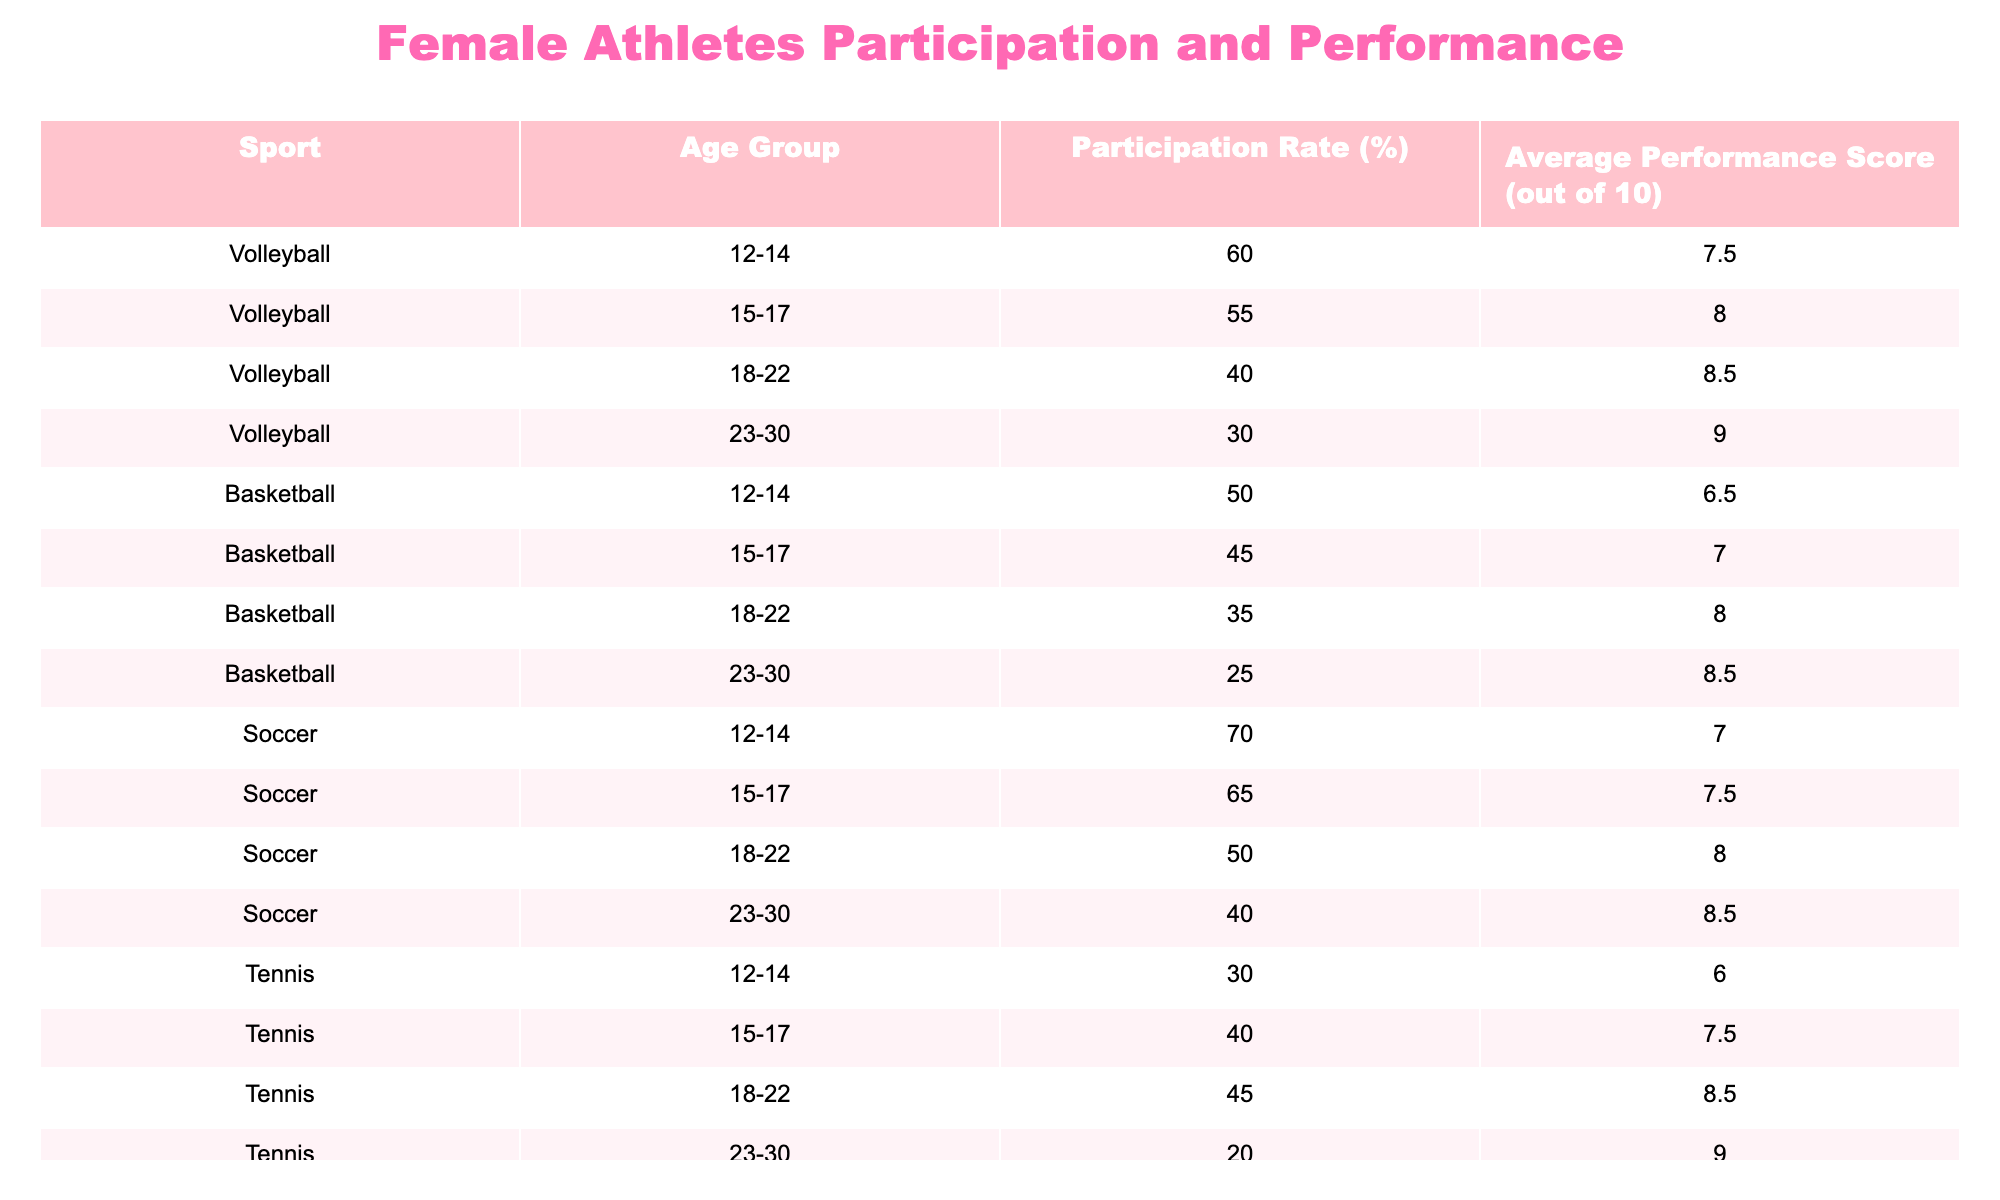What is the participation rate for female athletes in volleyball aged 12-14? According to the table, the participation rate for female athletes in volleyball in the age group of 12-14 is specified directly in the corresponding row, which shows a percentage of 60.
Answer: 60% What sport has the highest participation rate in the age group of 15-17? By comparing the participation rates across different sports for the age group of 15-17, volleyball has a participation rate of 55%, basketball has 45%, soccer has 65%, and tennis has 40%. Among these, soccer has the highest rate at 65%.
Answer: Soccer What is the average performance score for female athletes in tennis aged 18-22? The table indicates the average performance score for female athletes aged 18-22 in tennis, which is recorded directly as 8.5 in the relevant row of the table.
Answer: 8.5 Is the average performance score for basketball in the age group of 23-30 higher than that for soccer in the same age group? The average performance score for basketball aged 23-30 is 8.5 while for soccer it is 8.5 as well. Since both scores are equal, the answer to whether basketball is higher than soccer is false.
Answer: No What is the difference in participation rates between swimming and volleyball for athletes aged 18-22? The participation rate for swimming in the 18-22 age group is 45%, while for volleyball, it is 40%. The difference is calculated by subtracting the volleyball rate from the swimming rate: 45 - 40 = 5%.
Answer: 5% What is the total average performance score of all sports for the age group 12-14? To find the total average performance score for the age group of 12-14, we sum the scores from each sport's data in that age group: volleyball (7.5) + basketball (6.5) + soccer (7.0) + tennis (6.0) + swimming (7.0) = 34.0. Then we divide by the number of sports (5): 34.0 / 5 = 6.8.
Answer: 6.8 Which age group has the lowest participation rate in soccer? From the table, soccer participation rates across age groups show that for 12-14 it is 70%, 15-17 is 65%, 18-22 is 50%, and 23-30 is 40%. The lowest rate appears in the 23-30 age group at 40%.
Answer: 23-30 Does the average performance score for volleyball in the age group 18-22 exceed the average performance score for swimming in the same age group? The average performance score for volleyball aged 18-22 is 8.5, while for swimming it is 8.2. Since 8.5 is greater than 8.2, the statement is true.
Answer: Yes 